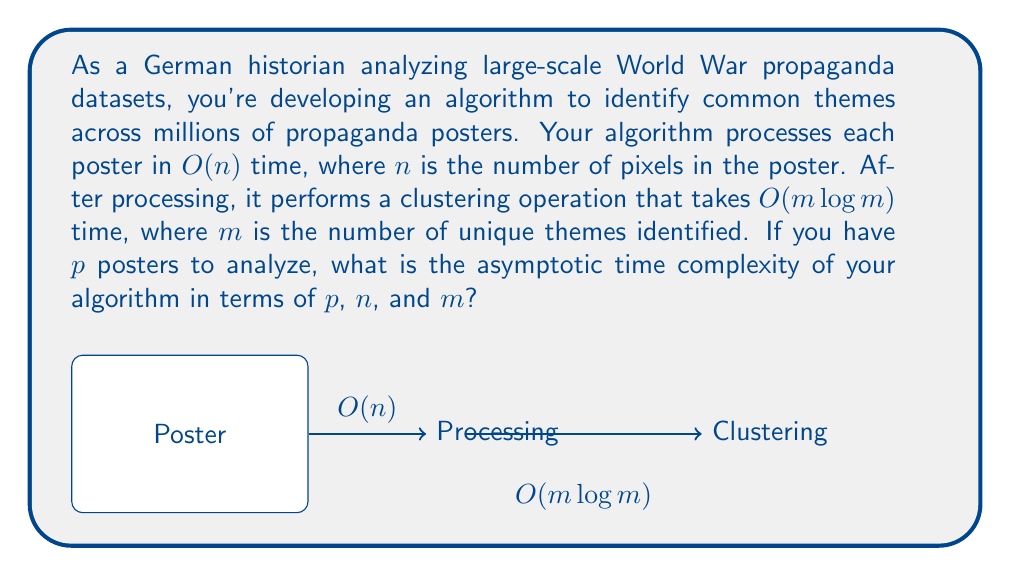Could you help me with this problem? Let's break this down step-by-step:

1) First, we process each poster individually. This takes $O(n)$ time per poster.

2) We have $p$ posters in total, so the total time for processing all posters is:

   $$O(p \cdot n)$$

3) After processing all posters, we perform a clustering operation. This operation takes $O(m \log m)$ time.

4) To get the total time complexity, we add these two components:

   $$O(p \cdot n) + O(m \log m)$$

5) In asymptotic notation, we keep the term that grows the fastest. However, in this case, we can't directly compare these terms because they depend on different variables.

6) Therefore, we keep both terms and express the total time complexity as:

   $$O(p \cdot n + m \log m)$$

This expression represents the asymptotic upper bound of the algorithm's running time.
Answer: $O(p \cdot n + m \log m)$ 